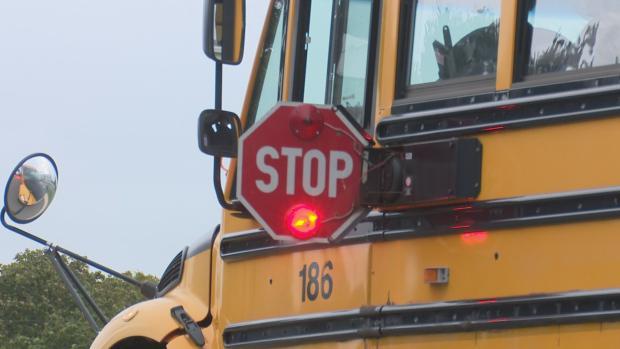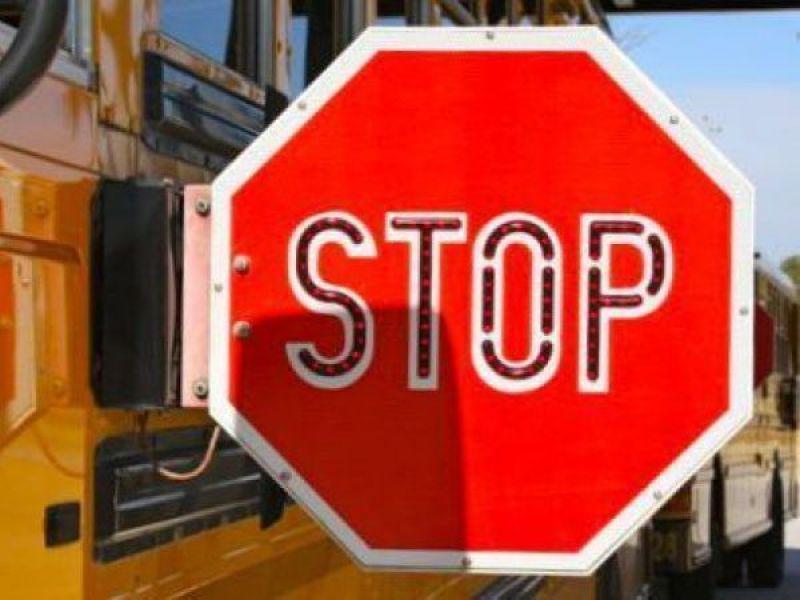The first image is the image on the left, the second image is the image on the right. Examine the images to the left and right. Is the description "Exactly two stop signs are extended." accurate? Answer yes or no. Yes. The first image is the image on the left, the second image is the image on the right. Given the left and right images, does the statement "Each image includes a red octagonal sign with a word between two red lights on the top and bottom, and in one image, the top light appears illuminated." hold true? Answer yes or no. No. 